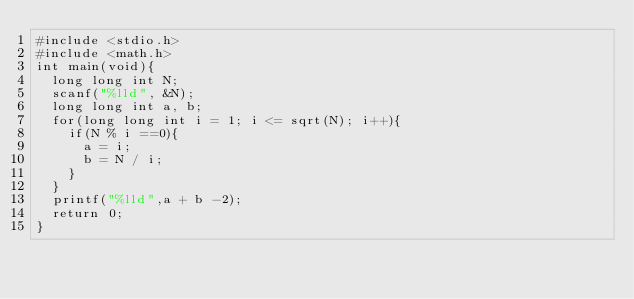Convert code to text. <code><loc_0><loc_0><loc_500><loc_500><_C++_>#include <stdio.h>
#include <math.h>
int main(void){
  long long int N;
  scanf("%lld", &N);
  long long int a, b;
  for(long long int i = 1; i <= sqrt(N); i++){
  	if(N % i ==0){
  		a = i;
  		b = N / i;
  	}
  }
  printf("%lld",a + b -2);
  return 0;
}</code> 